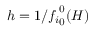Convert formula to latex. <formula><loc_0><loc_0><loc_500><loc_500>h = 1 / { f _ { i } } _ { 0 } ^ { 0 } ( H )</formula> 